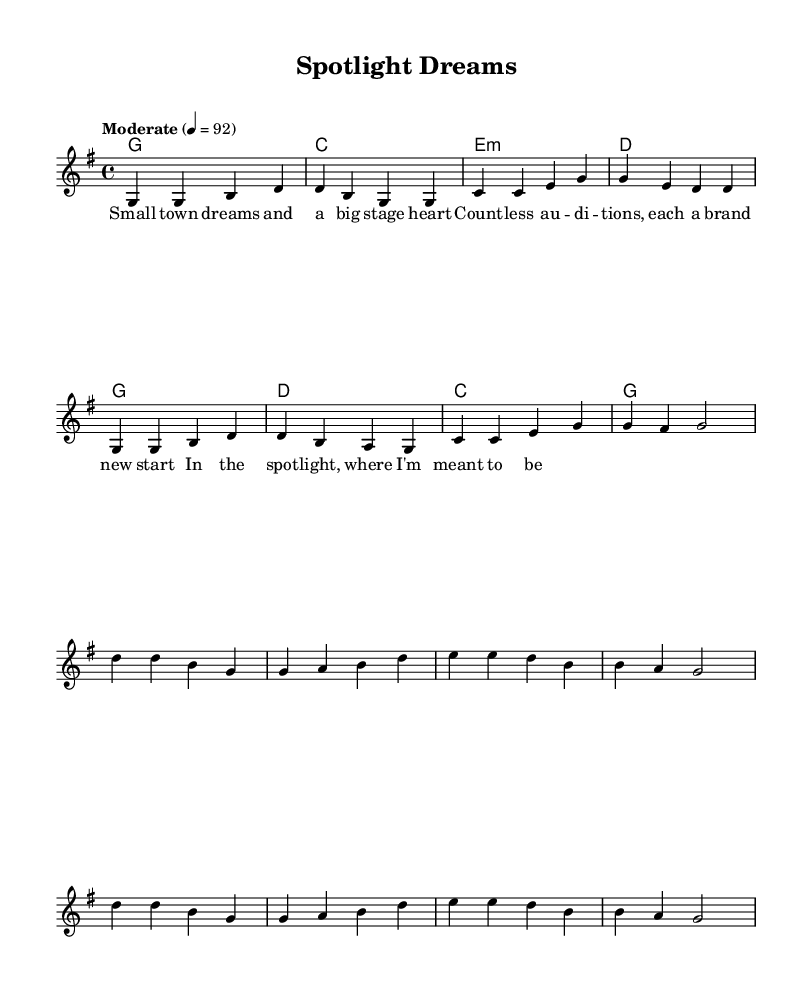What is the key signature of this music? The key signature shows one sharp, indicating it is in G major.
Answer: G major What is the time signature of this music? The time signature is found at the beginning of the staff, which is 4/4, meaning there are four beats in a measure.
Answer: 4/4 What is the tempo marking for this piece? The tempo indication is labeled as "Moderate" with a metronome marking of 92, indicating the piece should be played at this speed.
Answer: Moderate 4 = 92 How many lines are in the staff for the melody? The standard staff for the melody contains five lines, which is typical for treble clef notation.
Answer: Five lines What message do the lyrics of the chorus convey about the singer's aspirations? The lyrics express a strong belief in pursuing dreams and belonging on stage, emphasizing confidence and ambition.
Answer: Achieving dreams What chords are used in the first two measures of the verse? The first two measures contain G major and G major chords, which set the foundation for the melody.
Answer: G major In which part of the song do the lyrics reflect overcoming adversity? The verse lyrics illustrate the struggles of facing auditions, highlighting the journey of overcoming challenges.
Answer: Verse 